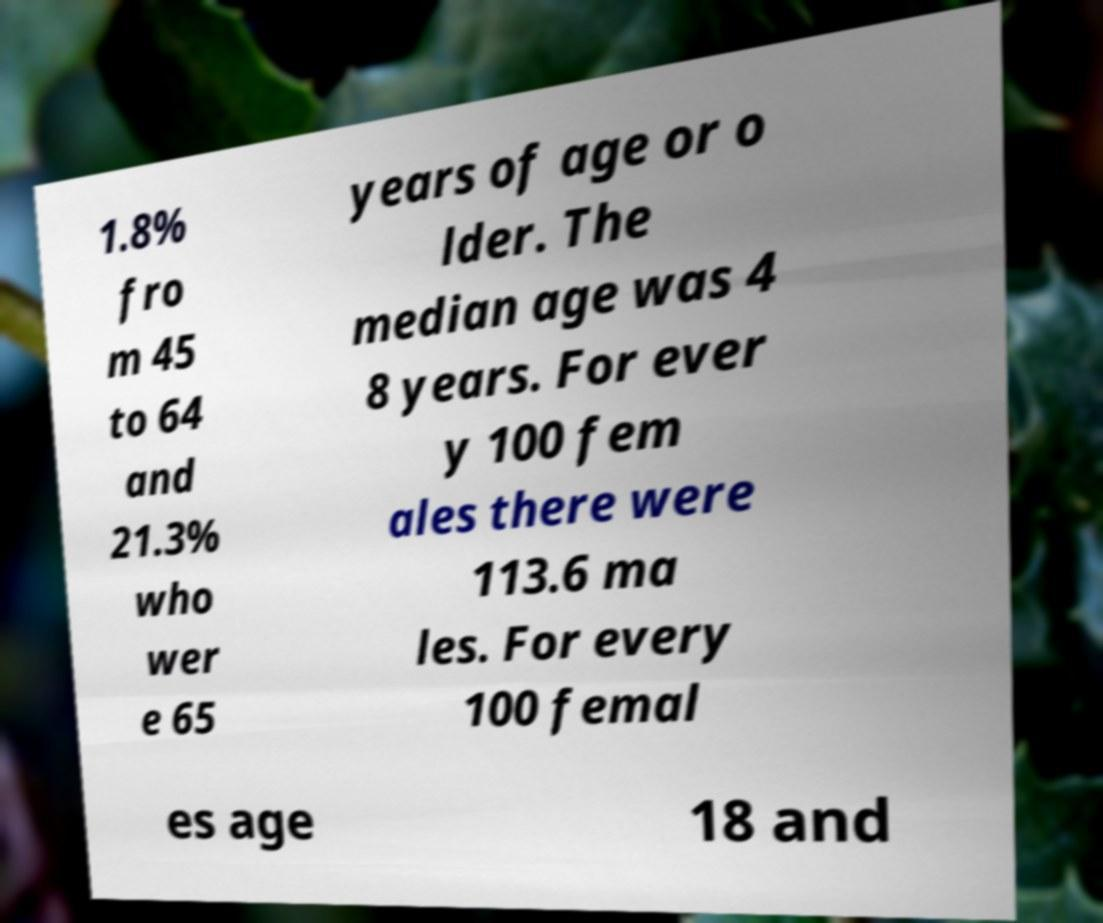Could you assist in decoding the text presented in this image and type it out clearly? 1.8% fro m 45 to 64 and 21.3% who wer e 65 years of age or o lder. The median age was 4 8 years. For ever y 100 fem ales there were 113.6 ma les. For every 100 femal es age 18 and 